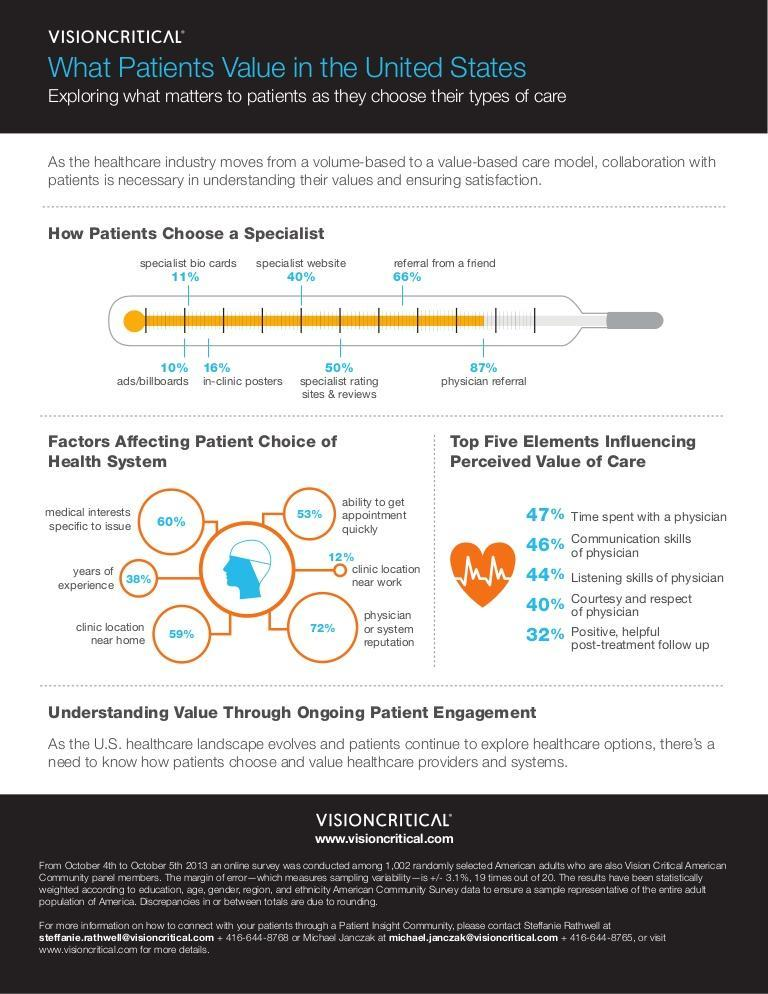What is the least preferred way of choosing a specialist by a patient in U.S.?
Answer the question with a short phrase. ads/billboards Which is the least important factor that affects the patient's choice of health system in U.S.? clinic location near work What percent of patients choose a specialist depending on in-clinic posters in U.S.? 16% Which is the most important factor that affects the patient's choice of health system in the  U.S.? physician or system reputation What is the most preferred way of choosing a specialist by a patient in U.S.? physician referral What percent of patients choose a specialist depending on the specialist's website in U.S.? 40% 